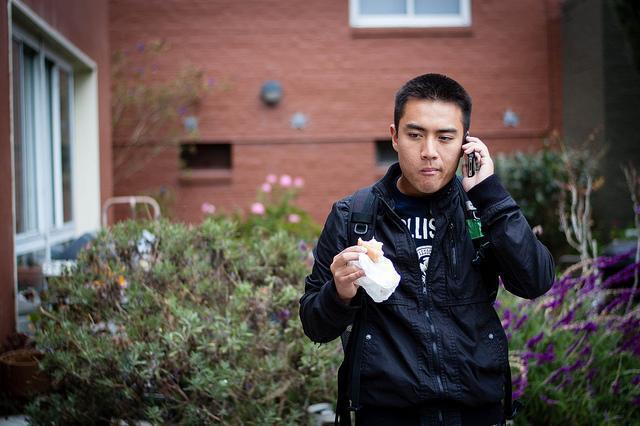How many tracks have a train on them?
Give a very brief answer. 0. 